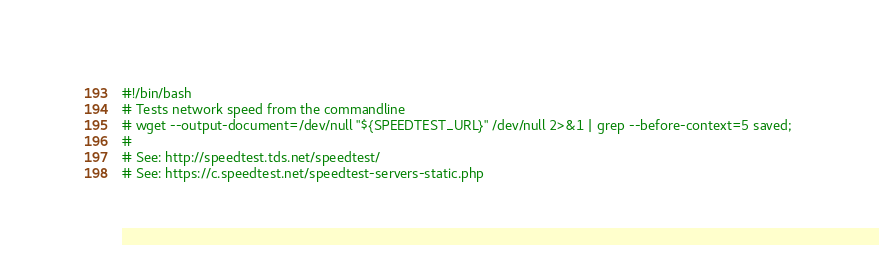Convert code to text. <code><loc_0><loc_0><loc_500><loc_500><_Bash_>#!/bin/bash
# Tests network speed from the commandline
# wget --output-document=/dev/null "${SPEEDTEST_URL}" /dev/null 2>&1 | grep --before-context=5 saved; 
#
# See: http://speedtest.tds.net/speedtest/
# See: https://c.speedtest.net/speedtest-servers-static.php
</code> 